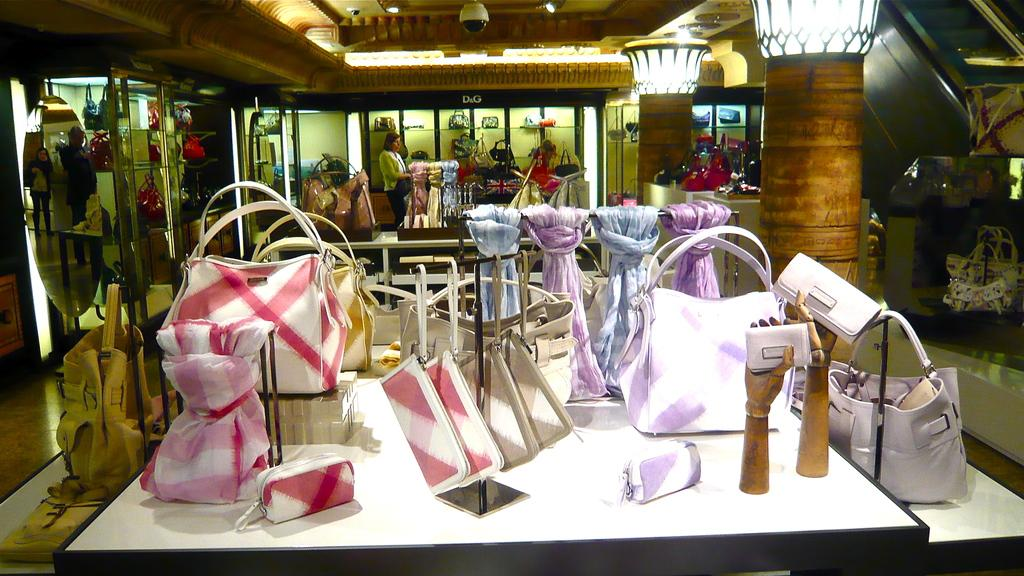What type of store is depicted in the image? The image is of a bag store. What items can be found in the store? There are bags and scarves in the store. What service is provided in the store? There are valets in the store. Is there a way for customers to check their appearance in the store? Yes, there is a mirror in the store. Can you describe the woman visible in the mirror reflection? The woman is visible in the mirror reflection, at a distance. What is the view like outside the store during a thunderstorm? The image does not show any view outside the store or any indication of a thunderstorm, so it cannot be determined from the image. 